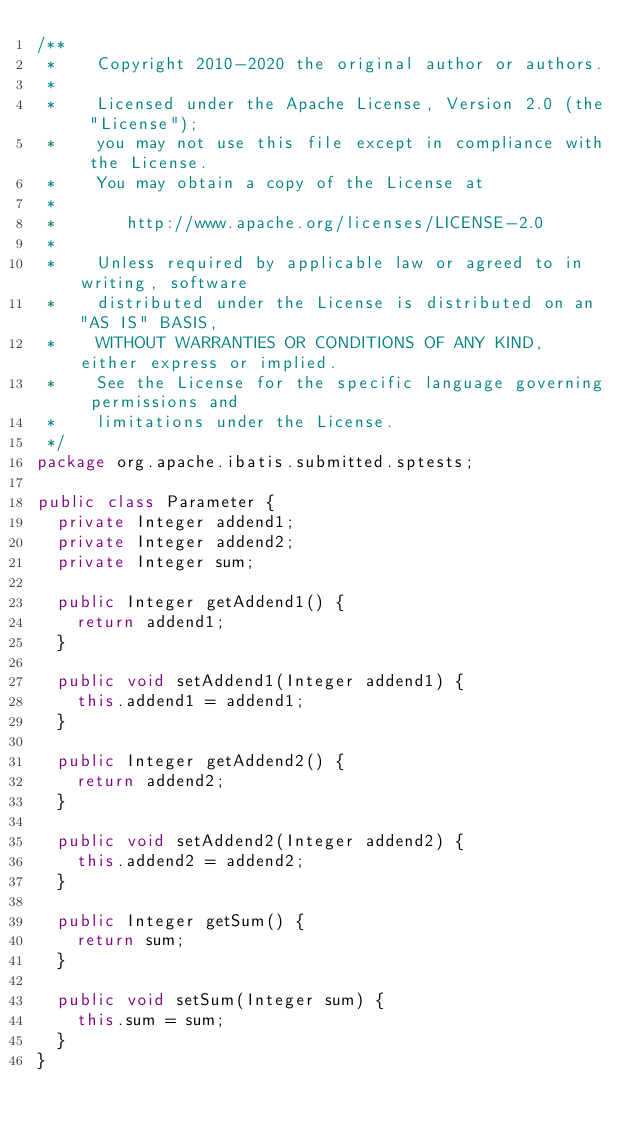<code> <loc_0><loc_0><loc_500><loc_500><_Java_>/**
 *    Copyright 2010-2020 the original author or authors.
 *
 *    Licensed under the Apache License, Version 2.0 (the "License");
 *    you may not use this file except in compliance with the License.
 *    You may obtain a copy of the License at
 *
 *       http://www.apache.org/licenses/LICENSE-2.0
 *
 *    Unless required by applicable law or agreed to in writing, software
 *    distributed under the License is distributed on an "AS IS" BASIS,
 *    WITHOUT WARRANTIES OR CONDITIONS OF ANY KIND, either express or implied.
 *    See the License for the specific language governing permissions and
 *    limitations under the License.
 */
package org.apache.ibatis.submitted.sptests;

public class Parameter {
  private Integer addend1;
  private Integer addend2;
  private Integer sum;

  public Integer getAddend1() {
    return addend1;
  }

  public void setAddend1(Integer addend1) {
    this.addend1 = addend1;
  }

  public Integer getAddend2() {
    return addend2;
  }

  public void setAddend2(Integer addend2) {
    this.addend2 = addend2;
  }

  public Integer getSum() {
    return sum;
  }

  public void setSum(Integer sum) {
    this.sum = sum;
  }
}
</code> 